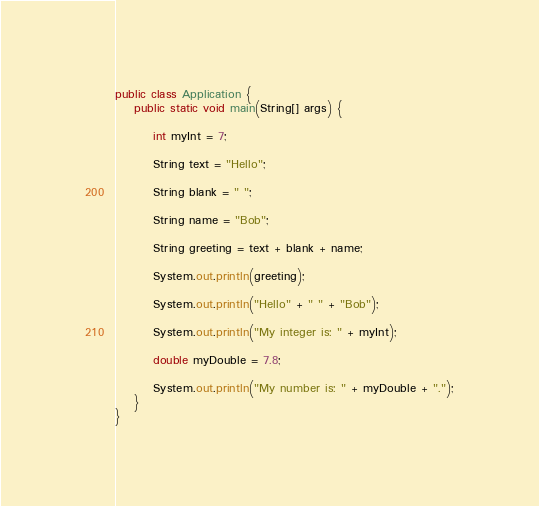Convert code to text. <code><loc_0><loc_0><loc_500><loc_500><_Java_>public class Application {
    public static void main(String[] args) {
         
        int myInt = 7;
         
        String text = "Hello";
         
        String blank = " ";
         
        String name = "Bob";
         
        String greeting = text + blank + name;
         
        System.out.println(greeting);
         
        System.out.println("Hello" + " " + "Bob");
         
        System.out.println("My integer is: " + myInt);
         
        double myDouble = 7.8;
         
        System.out.println("My number is: " + myDouble + ".");
    }
}</code> 